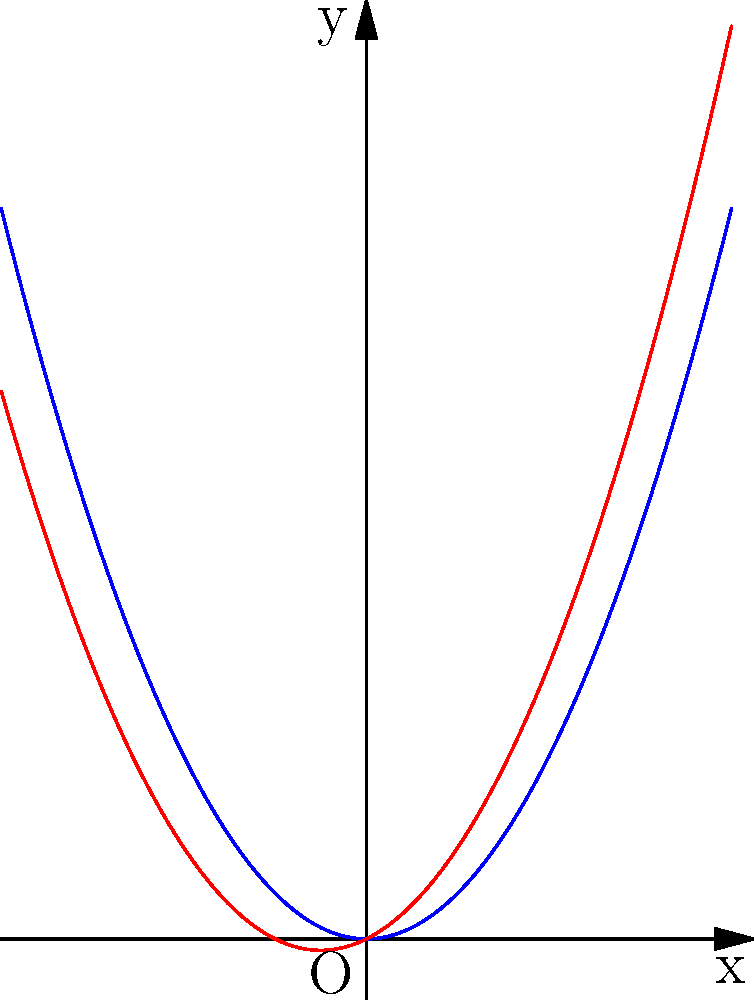The blue curve represents the original trajectory of a judo throw technique, given by the function $f(x) = x^2$. After applying a shear transformation, the new trajectory is represented by the red curve. If the shear factor is $k = 0.5$ in the x-direction, what is the equation of the sheared trajectory $g(x)$? To determine the equation of the sheared trajectory, we need to follow these steps:

1) The general form of a shear transformation in the x-direction is:
   $x' = x + ky$
   $y' = y$

2) In this case, we're shearing the function $f(x) = x^2$ with a shear factor of $k = 0.5$.

3) To find the new function $g(x)$, we need to substitute $x$ in the original function with $(x - ky)$:
   $g(x) = (x - ky)^2$

4) Since $y = x^2$ (the original function), we can substitute this:
   $g(x) = (x - k(x^2))^2$

5) Simplifying with $k = 0.5$:
   $g(x) = (x - 0.5x^2)^2$

6) Expanding this:
   $g(x) = x^2 - x^3 + 0.25x^4$

7) However, we can simplify this further. In a shear transformation, the y-coordinate of each point changes by $kx$:
   $g(x) = f(x) + kx = x^2 + 0.5x$

Therefore, the equation of the sheared trajectory is $g(x) = x^2 + 0.5x$.
Answer: $g(x) = x^2 + 0.5x$ 